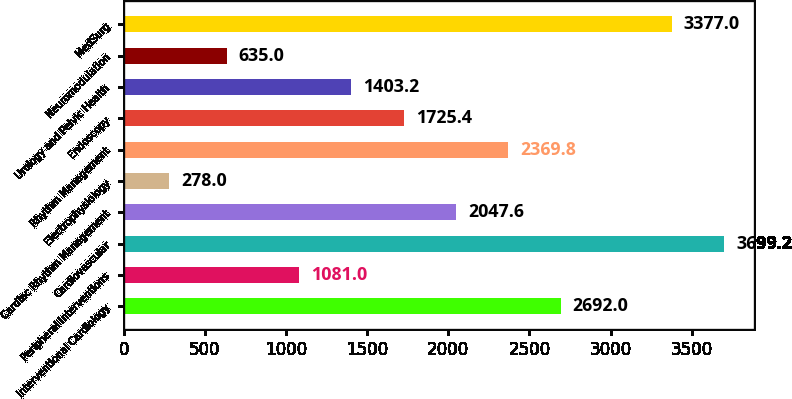Convert chart to OTSL. <chart><loc_0><loc_0><loc_500><loc_500><bar_chart><fcel>Interventional Cardiology<fcel>Peripheral Interventions<fcel>Cardiovascular<fcel>Cardiac Rhythm Management<fcel>Electrophysiology<fcel>Rhythm Management<fcel>Endoscopy<fcel>Urology and Pelvic Health<fcel>Neuromodulation<fcel>MedSurg<nl><fcel>2692<fcel>1081<fcel>3699.2<fcel>2047.6<fcel>278<fcel>2369.8<fcel>1725.4<fcel>1403.2<fcel>635<fcel>3377<nl></chart> 